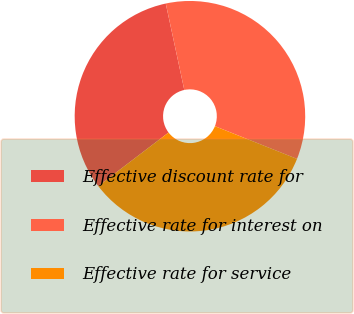<chart> <loc_0><loc_0><loc_500><loc_500><pie_chart><fcel>Effective discount rate for<fcel>Effective rate for interest on<fcel>Effective rate for service<nl><fcel>32.0%<fcel>34.4%<fcel>33.6%<nl></chart> 